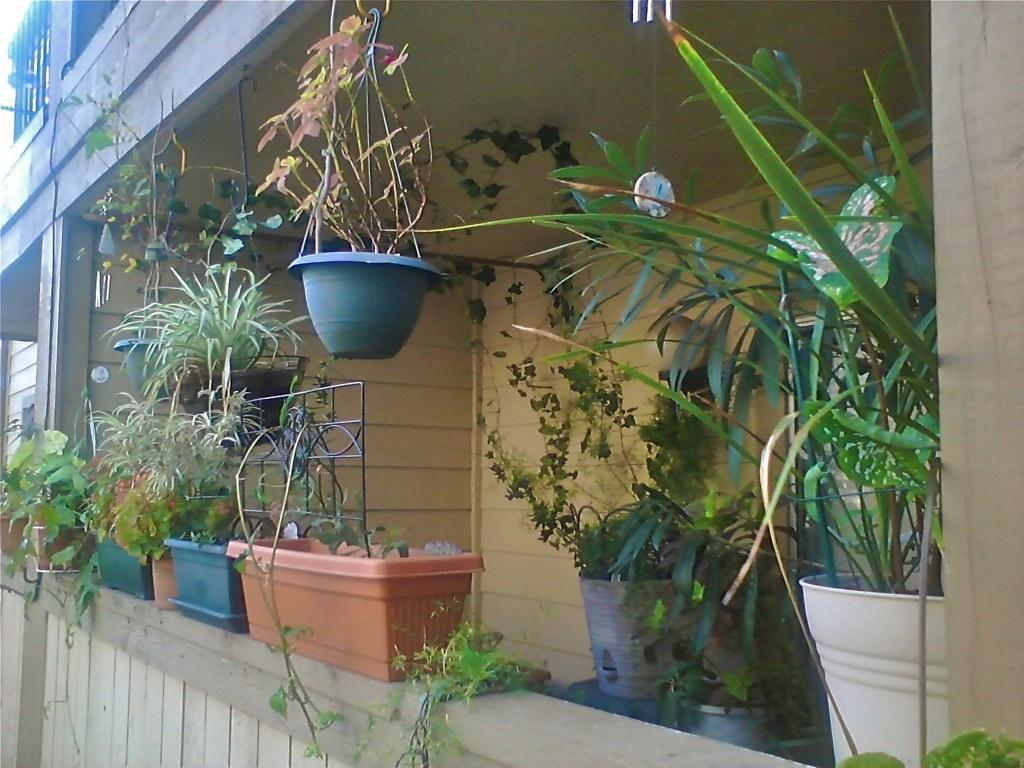Describe this image in one or two sentences. In this image we can see a building, there are some house plants on the wall and we can see some grills and a window. 